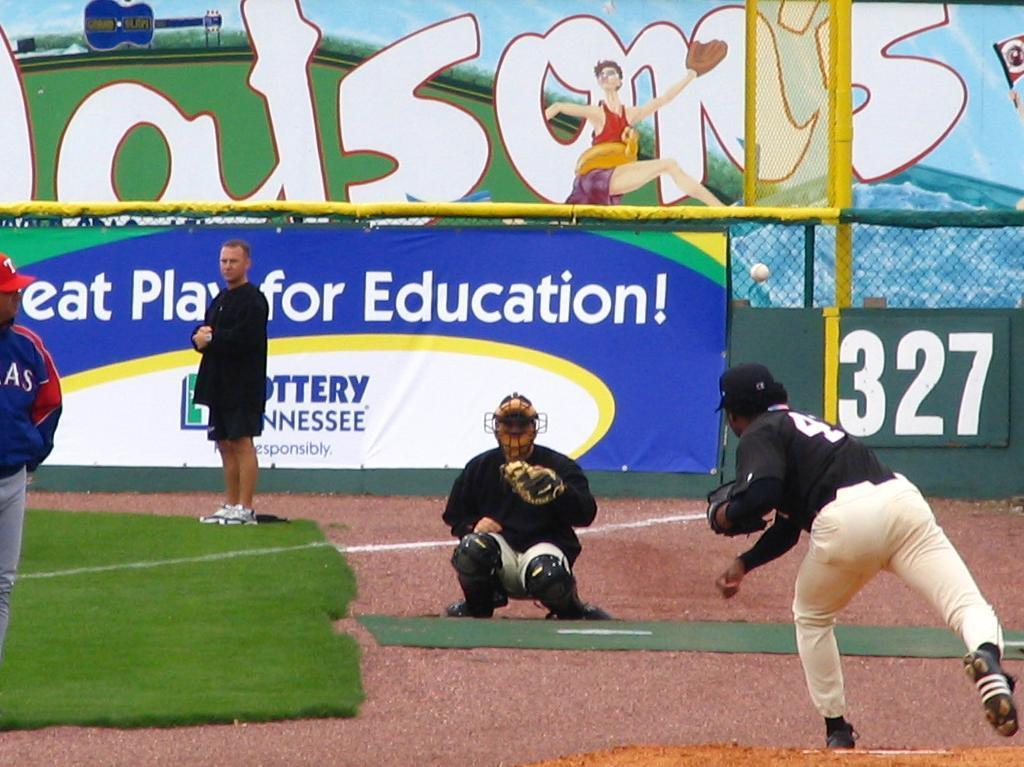<image>
Provide a brief description of the given image. Baseball game happening in front of an ad that says "Great Play for Education!". 